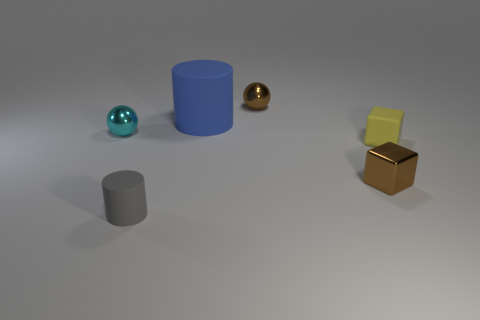Add 2 cubes. How many objects exist? 8 Subtract 1 cylinders. How many cylinders are left? 1 Subtract 0 red spheres. How many objects are left? 6 Subtract all spheres. How many objects are left? 4 Subtract all green blocks. Subtract all blue cylinders. How many blocks are left? 2 Subtract all cyan cubes. How many cyan spheres are left? 1 Subtract all large things. Subtract all yellow cubes. How many objects are left? 4 Add 3 metallic balls. How many metallic balls are left? 5 Add 1 rubber cubes. How many rubber cubes exist? 2 